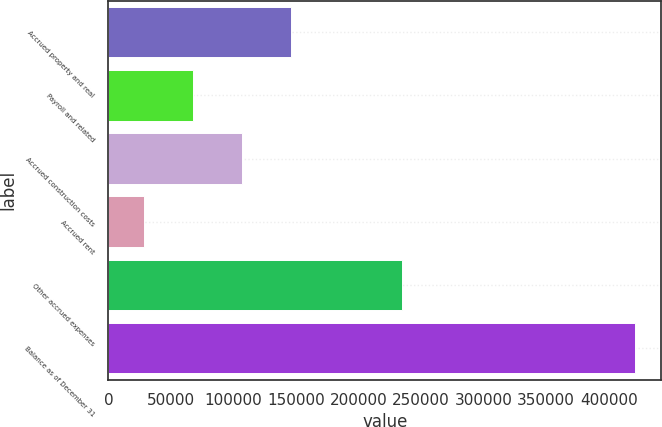<chart> <loc_0><loc_0><loc_500><loc_500><bar_chart><fcel>Accrued property and real<fcel>Payroll and related<fcel>Accrued construction costs<fcel>Accrued rent<fcel>Other accrued expenses<fcel>Balance as of December 31<nl><fcel>146276<fcel>67729.2<fcel>107002<fcel>28456<fcel>234914<fcel>421188<nl></chart> 